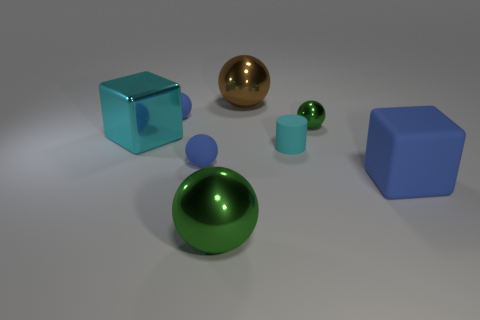Is the large brown ball made of the same material as the big green sphere?
Offer a very short reply. Yes. Are there any large green objects that are behind the small blue matte thing that is in front of the tiny green shiny object?
Offer a terse response. No. Is there a small cyan rubber object that has the same shape as the small green thing?
Make the answer very short. No. Do the shiny cube and the large matte object have the same color?
Keep it short and to the point. No. The big block on the right side of the green shiny thing to the left of the big brown thing is made of what material?
Your answer should be compact. Rubber. The brown ball is what size?
Keep it short and to the point. Large. There is a cyan object that is the same material as the big blue thing; what is its size?
Ensure brevity in your answer.  Small. There is a green ball that is in front of the rubber cube; is it the same size as the big rubber block?
Your answer should be compact. Yes. What shape is the green object that is in front of the blue thing to the right of the green shiny object that is in front of the matte block?
Keep it short and to the point. Sphere. What number of objects are either large blue blocks or shiny objects that are in front of the small green thing?
Your answer should be compact. 3. 